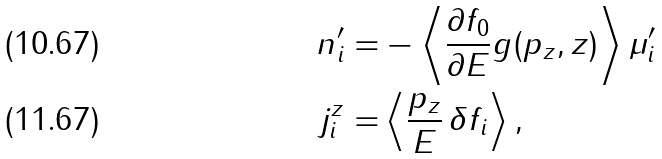Convert formula to latex. <formula><loc_0><loc_0><loc_500><loc_500>n ^ { \prime } _ { i } = & - \left < \frac { \partial f _ { 0 } } { \partial E } g ( p _ { z } , z ) \right > \mu ^ { \prime } _ { i } \\ j _ { i } ^ { z } = & \left < \frac { p _ { z } } { E } \, \delta f _ { i } \right > ,</formula> 